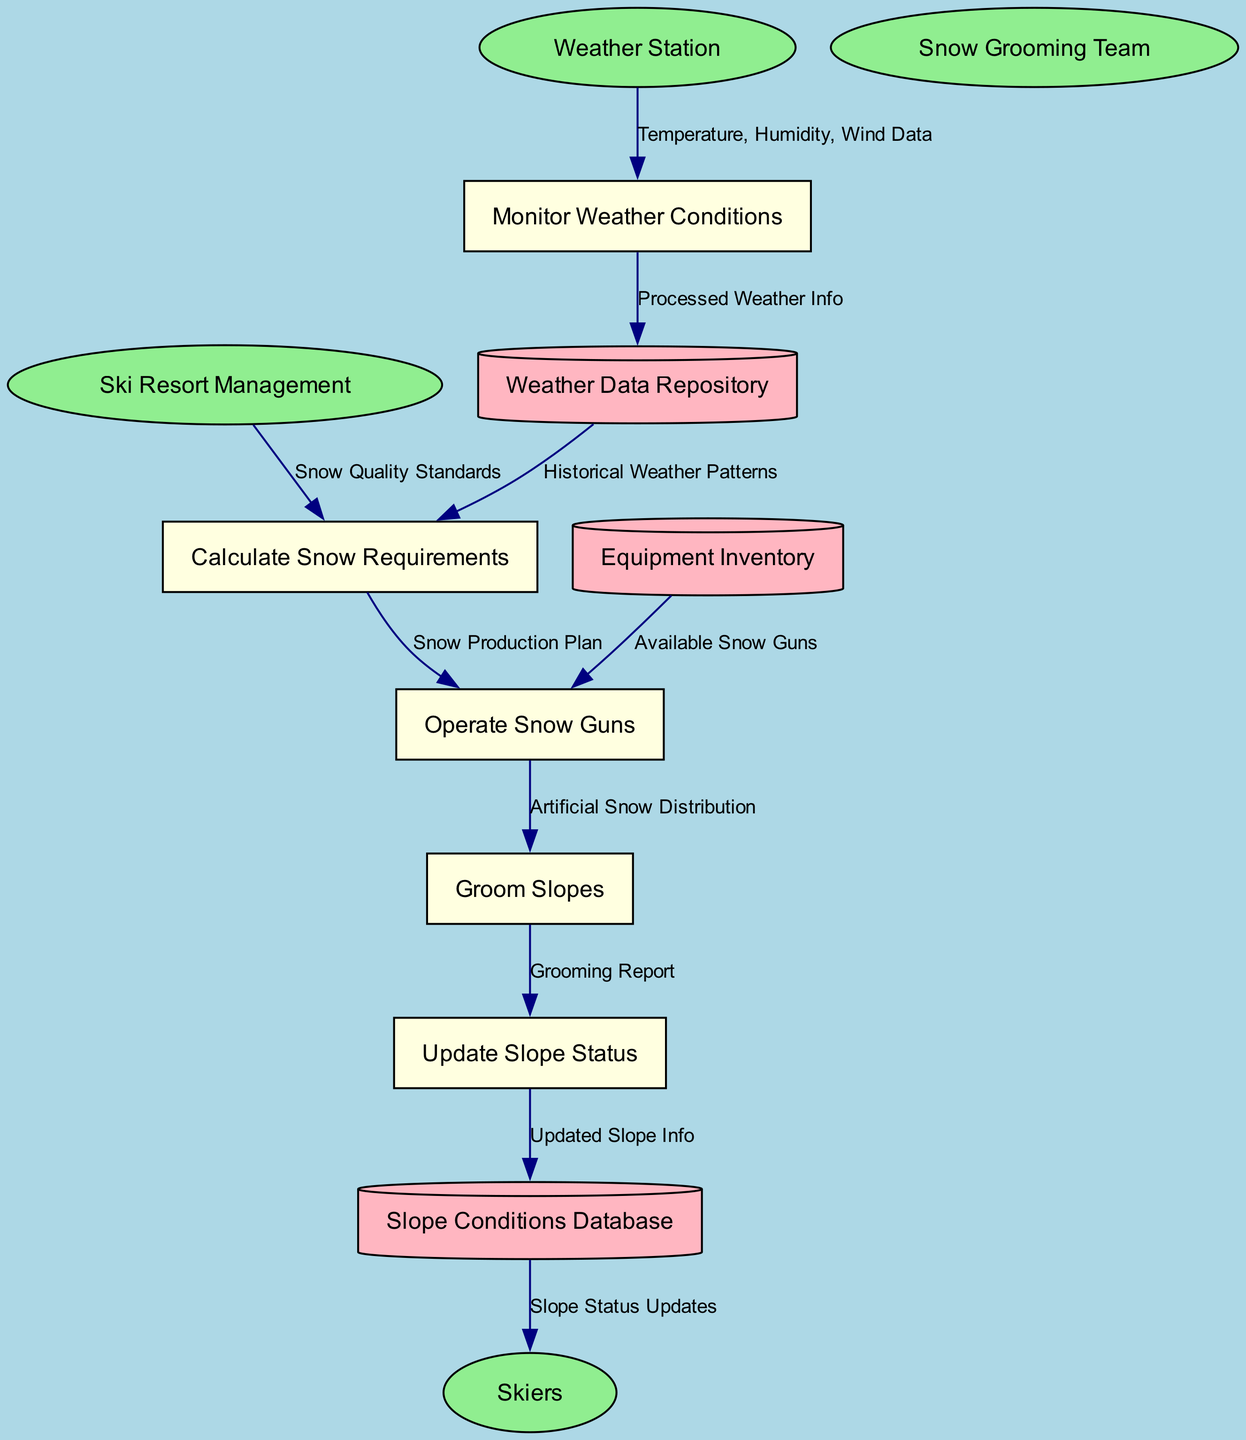What are the external entities in this diagram? The external entities are labeled as ellipses in the diagram. The entities listed include Ski Resort Management, Weather Station, Snow Grooming Team, and Skiers.
Answer: Ski Resort Management, Weather Station, Snow Grooming Team, Skiers How many processes are represented in the diagram? The diagram contains five processes that control the workflow for snow production and grooming, identified by their rectangular nodes: Monitor Weather Conditions, Calculate Snow Requirements, Operate Snow Guns, Groom Slopes, and Update Slope Status.
Answer: Five Which process follows the 'Calculate Snow Requirements'? The data flow indicates that after 'Calculate Snow Requirements', the next process is 'Operate Snow Guns', as shown by the directional arrows connecting these two processes.
Answer: Operate Snow Guns What data flows from the Weather Station to the Monitor Weather Conditions process? The flow labeled "Temperature, Humidity, Wind Data" indicates the specific data that is sent from the Weather Station to the Monitor Weather Conditions process.
Answer: Temperature, Humidity, Wind Data Which external entity sends "Snow Quality Standards" to "Calculate Snow Requirements"? The diagram shows that the external entity Ski Resort Management is responsible for sending "Snow Quality Standards" to the Calculate Snow Requirements process, indicating a relationship between them.
Answer: Ski Resort Management In which data store is the updated slope information kept? The updated slope information flows into the Slope Conditions Database from the Update Slope Status process, highlighting the storage system for this information.
Answer: Slope Conditions Database What does the Operate Snow Guns process require from the Equipment Inventory? The Operate Snow Guns process requires "Available Snow Guns" from the Equipment Inventory to fulfill its function, which is indicated by the connecting data flow.
Answer: Available Snow Guns Which process generates the "Grooming Report"? The Groom Slopes process creates the "Grooming Report", as demonstrated by the flow leading from Groom Slopes to Update Slope Status, which carries this report.
Answer: Groom Slopes How does the Slope Conditions Database communicate with the Skiers? The Slope Conditions Database sends "Slope Status Updates" to the Skiers, as illustrated by the data flow directing information out from the database to the external entity.
Answer: Slope Status Updates 